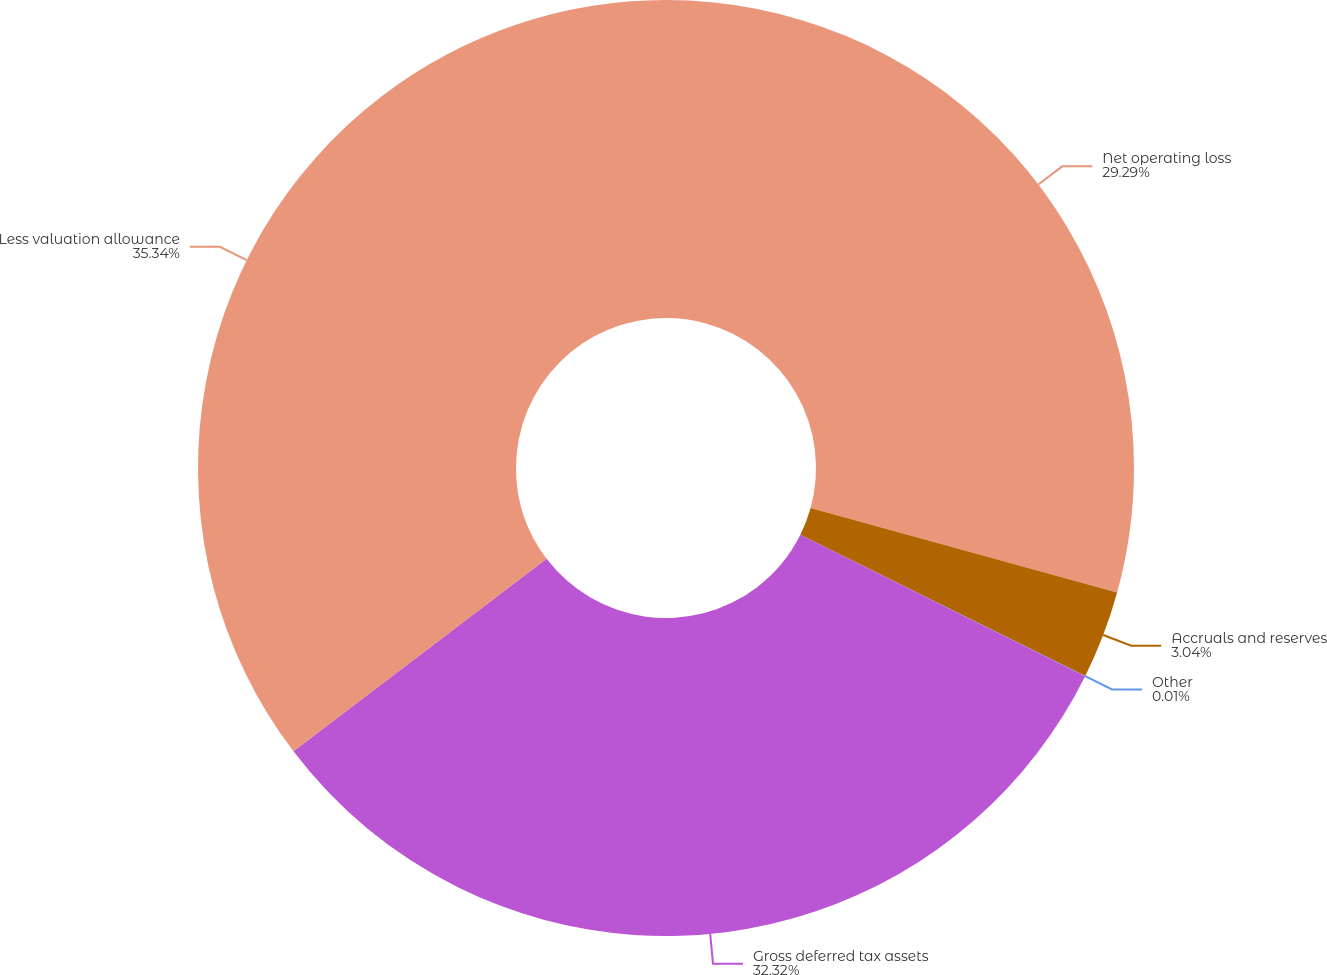Convert chart. <chart><loc_0><loc_0><loc_500><loc_500><pie_chart><fcel>Net operating loss<fcel>Accruals and reserves<fcel>Other<fcel>Gross deferred tax assets<fcel>Less valuation allowance<nl><fcel>29.29%<fcel>3.04%<fcel>0.01%<fcel>32.32%<fcel>35.35%<nl></chart> 